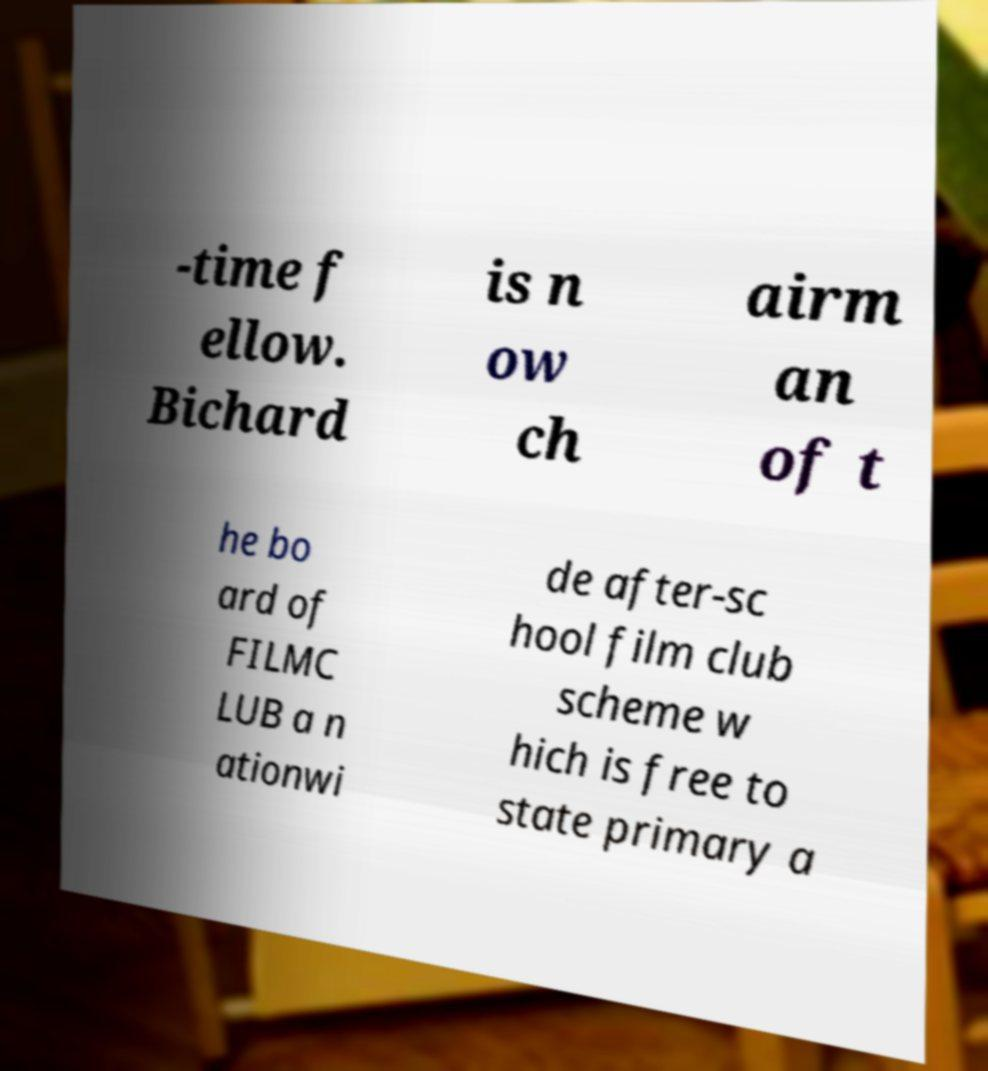I need the written content from this picture converted into text. Can you do that? -time f ellow. Bichard is n ow ch airm an of t he bo ard of FILMC LUB a n ationwi de after-sc hool film club scheme w hich is free to state primary a 